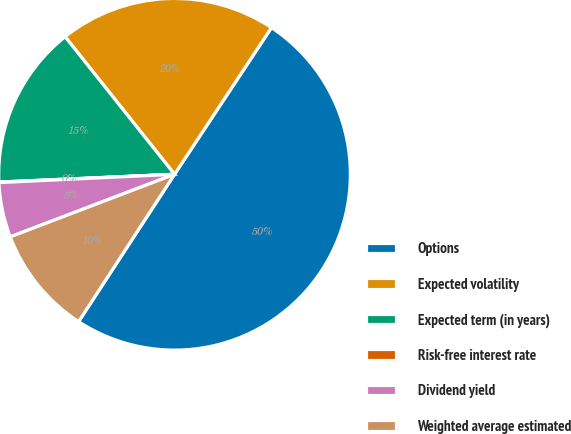Convert chart. <chart><loc_0><loc_0><loc_500><loc_500><pie_chart><fcel>Options<fcel>Expected volatility<fcel>Expected term (in years)<fcel>Risk-free interest rate<fcel>Dividend yield<fcel>Weighted average estimated<nl><fcel>49.9%<fcel>19.99%<fcel>15.01%<fcel>0.05%<fcel>5.04%<fcel>10.02%<nl></chart> 